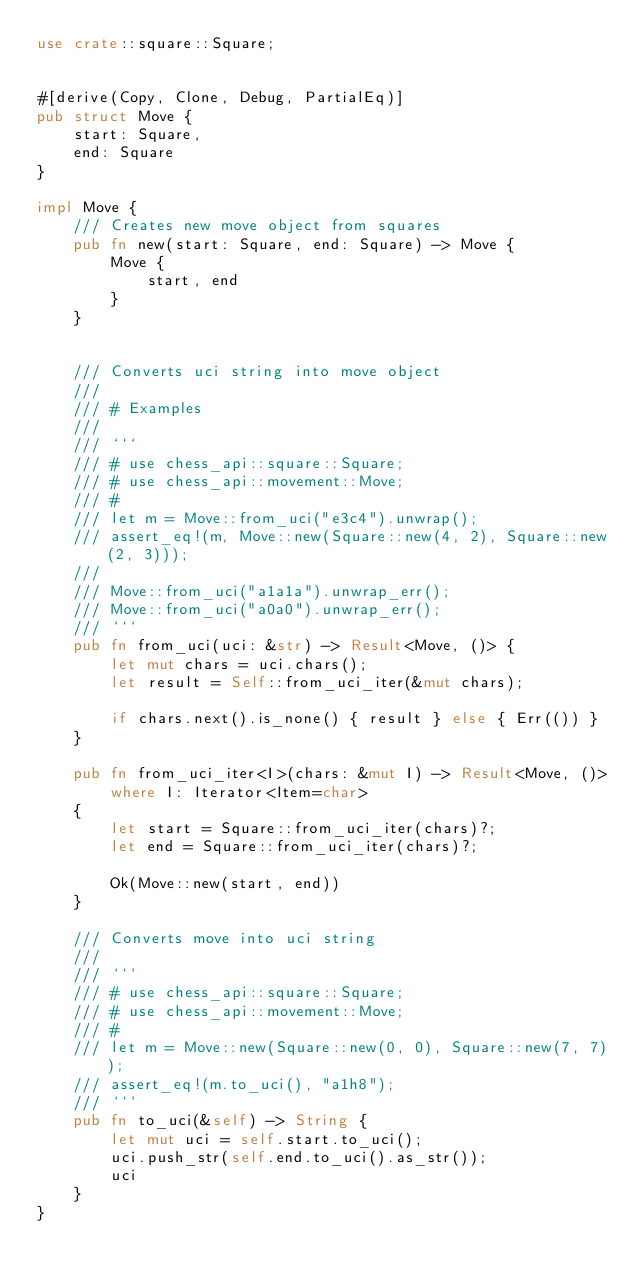<code> <loc_0><loc_0><loc_500><loc_500><_Rust_>use crate::square::Square;


#[derive(Copy, Clone, Debug, PartialEq)]
pub struct Move {
    start: Square,
    end: Square
}

impl Move {
    /// Creates new move object from squares
    pub fn new(start: Square, end: Square) -> Move {
        Move {
            start, end
        }
    }


    /// Converts uci string into move object
    ///
    /// # Examples
    ///
    /// ```
    /// # use chess_api::square::Square;
    /// # use chess_api::movement::Move;
    /// #
    /// let m = Move::from_uci("e3c4").unwrap();
    /// assert_eq!(m, Move::new(Square::new(4, 2), Square::new(2, 3)));
    ///
    /// Move::from_uci("a1a1a").unwrap_err();
    /// Move::from_uci("a0a0").unwrap_err();
    /// ```
    pub fn from_uci(uci: &str) -> Result<Move, ()> {
        let mut chars = uci.chars();
        let result = Self::from_uci_iter(&mut chars);

        if chars.next().is_none() { result } else { Err(()) }
    }

    pub fn from_uci_iter<I>(chars: &mut I) -> Result<Move, ()>
        where I: Iterator<Item=char>
    {
        let start = Square::from_uci_iter(chars)?;
        let end = Square::from_uci_iter(chars)?;

        Ok(Move::new(start, end))
    }

    /// Converts move into uci string
    ///
    /// ```
    /// # use chess_api::square::Square;
    /// # use chess_api::movement::Move;
    /// #
    /// let m = Move::new(Square::new(0, 0), Square::new(7, 7));
    /// assert_eq!(m.to_uci(), "a1h8");
    /// ```
    pub fn to_uci(&self) -> String {
        let mut uci = self.start.to_uci();
        uci.push_str(self.end.to_uci().as_str());
        uci
    }
}


</code> 